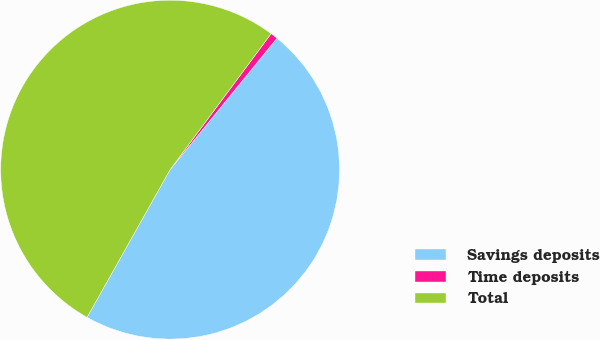Convert chart to OTSL. <chart><loc_0><loc_0><loc_500><loc_500><pie_chart><fcel>Savings deposits<fcel>Time deposits<fcel>Total<nl><fcel>47.29%<fcel>0.69%<fcel>52.02%<nl></chart> 